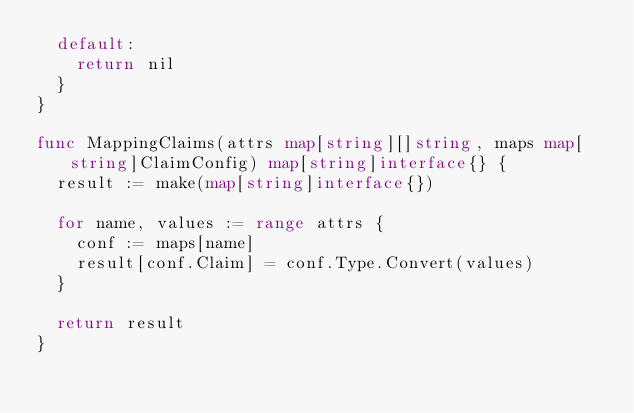<code> <loc_0><loc_0><loc_500><loc_500><_Go_>	default:
		return nil
	}
}

func MappingClaims(attrs map[string][]string, maps map[string]ClaimConfig) map[string]interface{} {
	result := make(map[string]interface{})

	for name, values := range attrs {
		conf := maps[name]
		result[conf.Claim] = conf.Type.Convert(values)
	}

	return result
}
</code> 